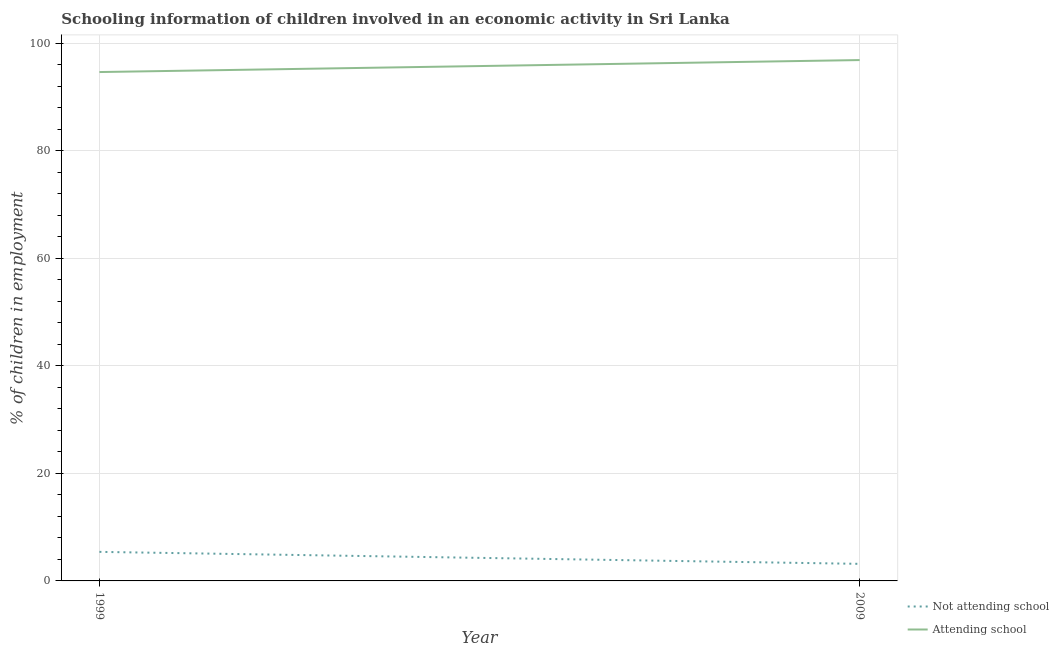How many different coloured lines are there?
Provide a succinct answer. 2. Does the line corresponding to percentage of employed children who are not attending school intersect with the line corresponding to percentage of employed children who are attending school?
Keep it short and to the point. No. What is the percentage of employed children who are attending school in 1999?
Ensure brevity in your answer.  94.6. Across all years, what is the maximum percentage of employed children who are attending school?
Your answer should be compact. 96.83. Across all years, what is the minimum percentage of employed children who are attending school?
Your answer should be compact. 94.6. In which year was the percentage of employed children who are not attending school minimum?
Provide a short and direct response. 2009. What is the total percentage of employed children who are attending school in the graph?
Give a very brief answer. 191.43. What is the difference between the percentage of employed children who are not attending school in 1999 and that in 2009?
Keep it short and to the point. 2.23. What is the difference between the percentage of employed children who are not attending school in 2009 and the percentage of employed children who are attending school in 1999?
Make the answer very short. -91.43. What is the average percentage of employed children who are attending school per year?
Offer a very short reply. 95.71. In the year 1999, what is the difference between the percentage of employed children who are not attending school and percentage of employed children who are attending school?
Provide a succinct answer. -89.2. What is the ratio of the percentage of employed children who are attending school in 1999 to that in 2009?
Give a very brief answer. 0.98. Is the percentage of employed children who are attending school in 1999 less than that in 2009?
Give a very brief answer. Yes. In how many years, is the percentage of employed children who are not attending school greater than the average percentage of employed children who are not attending school taken over all years?
Offer a terse response. 1. Does the percentage of employed children who are not attending school monotonically increase over the years?
Make the answer very short. No. Is the percentage of employed children who are not attending school strictly greater than the percentage of employed children who are attending school over the years?
Offer a very short reply. No. Is the percentage of employed children who are not attending school strictly less than the percentage of employed children who are attending school over the years?
Your response must be concise. Yes. How many years are there in the graph?
Offer a terse response. 2. What is the difference between two consecutive major ticks on the Y-axis?
Ensure brevity in your answer.  20. Are the values on the major ticks of Y-axis written in scientific E-notation?
Provide a succinct answer. No. Does the graph contain grids?
Your answer should be compact. Yes. Where does the legend appear in the graph?
Provide a short and direct response. Bottom right. What is the title of the graph?
Provide a succinct answer. Schooling information of children involved in an economic activity in Sri Lanka. Does "Age 65(male)" appear as one of the legend labels in the graph?
Provide a short and direct response. No. What is the label or title of the Y-axis?
Ensure brevity in your answer.  % of children in employment. What is the % of children in employment in Attending school in 1999?
Provide a succinct answer. 94.6. What is the % of children in employment of Not attending school in 2009?
Your answer should be very brief. 3.17. What is the % of children in employment in Attending school in 2009?
Ensure brevity in your answer.  96.83. Across all years, what is the maximum % of children in employment in Attending school?
Your answer should be very brief. 96.83. Across all years, what is the minimum % of children in employment in Not attending school?
Provide a short and direct response. 3.17. Across all years, what is the minimum % of children in employment of Attending school?
Ensure brevity in your answer.  94.6. What is the total % of children in employment of Not attending school in the graph?
Make the answer very short. 8.57. What is the total % of children in employment in Attending school in the graph?
Make the answer very short. 191.43. What is the difference between the % of children in employment of Not attending school in 1999 and that in 2009?
Provide a succinct answer. 2.23. What is the difference between the % of children in employment of Attending school in 1999 and that in 2009?
Ensure brevity in your answer.  -2.23. What is the difference between the % of children in employment in Not attending school in 1999 and the % of children in employment in Attending school in 2009?
Your answer should be compact. -91.43. What is the average % of children in employment in Not attending school per year?
Provide a short and direct response. 4.29. What is the average % of children in employment in Attending school per year?
Your answer should be very brief. 95.71. In the year 1999, what is the difference between the % of children in employment of Not attending school and % of children in employment of Attending school?
Give a very brief answer. -89.2. In the year 2009, what is the difference between the % of children in employment of Not attending school and % of children in employment of Attending school?
Offer a very short reply. -93.66. What is the ratio of the % of children in employment of Not attending school in 1999 to that in 2009?
Offer a terse response. 1.7. What is the difference between the highest and the second highest % of children in employment in Not attending school?
Give a very brief answer. 2.23. What is the difference between the highest and the second highest % of children in employment in Attending school?
Make the answer very short. 2.23. What is the difference between the highest and the lowest % of children in employment in Not attending school?
Offer a terse response. 2.23. What is the difference between the highest and the lowest % of children in employment of Attending school?
Your answer should be very brief. 2.23. 